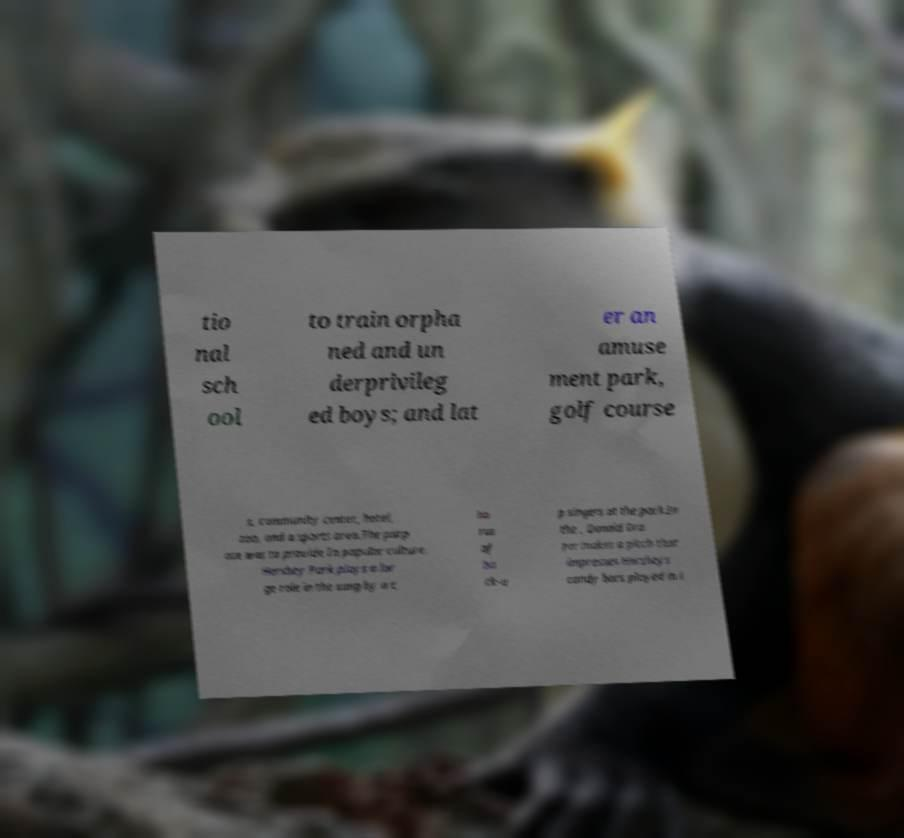Can you read and provide the text displayed in the image?This photo seems to have some interesting text. Can you extract and type it out for me? tio nal sch ool to train orpha ned and un derprivileg ed boys; and lat er an amuse ment park, golf course s, community center, hotel, zoo, and a sports area.The purp ose was to provide In popular culture. Hershey Park plays a lar ge role in the sung by a c ho rus of ba ck-u p singers at the park.In the , Donald Dra per makes a pitch that impresses Hersheys candy bars played in i 